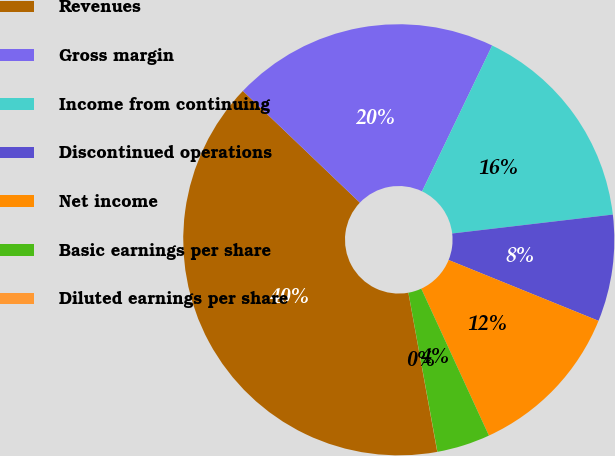<chart> <loc_0><loc_0><loc_500><loc_500><pie_chart><fcel>Revenues<fcel>Gross margin<fcel>Income from continuing<fcel>Discontinued operations<fcel>Net income<fcel>Basic earnings per share<fcel>Diluted earnings per share<nl><fcel>39.99%<fcel>20.0%<fcel>16.0%<fcel>8.0%<fcel>12.0%<fcel>4.0%<fcel>0.01%<nl></chart> 